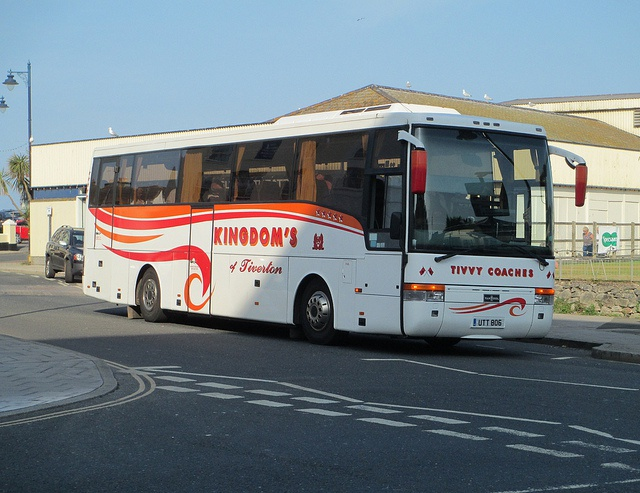Describe the objects in this image and their specific colors. I can see bus in lightblue, black, darkgray, ivory, and gray tones, car in lightblue, gray, darkgray, and black tones, people in lightblue, black, and gray tones, people in lightblue, darkgray, gray, and blue tones, and people in lightblue, gray, black, and maroon tones in this image. 